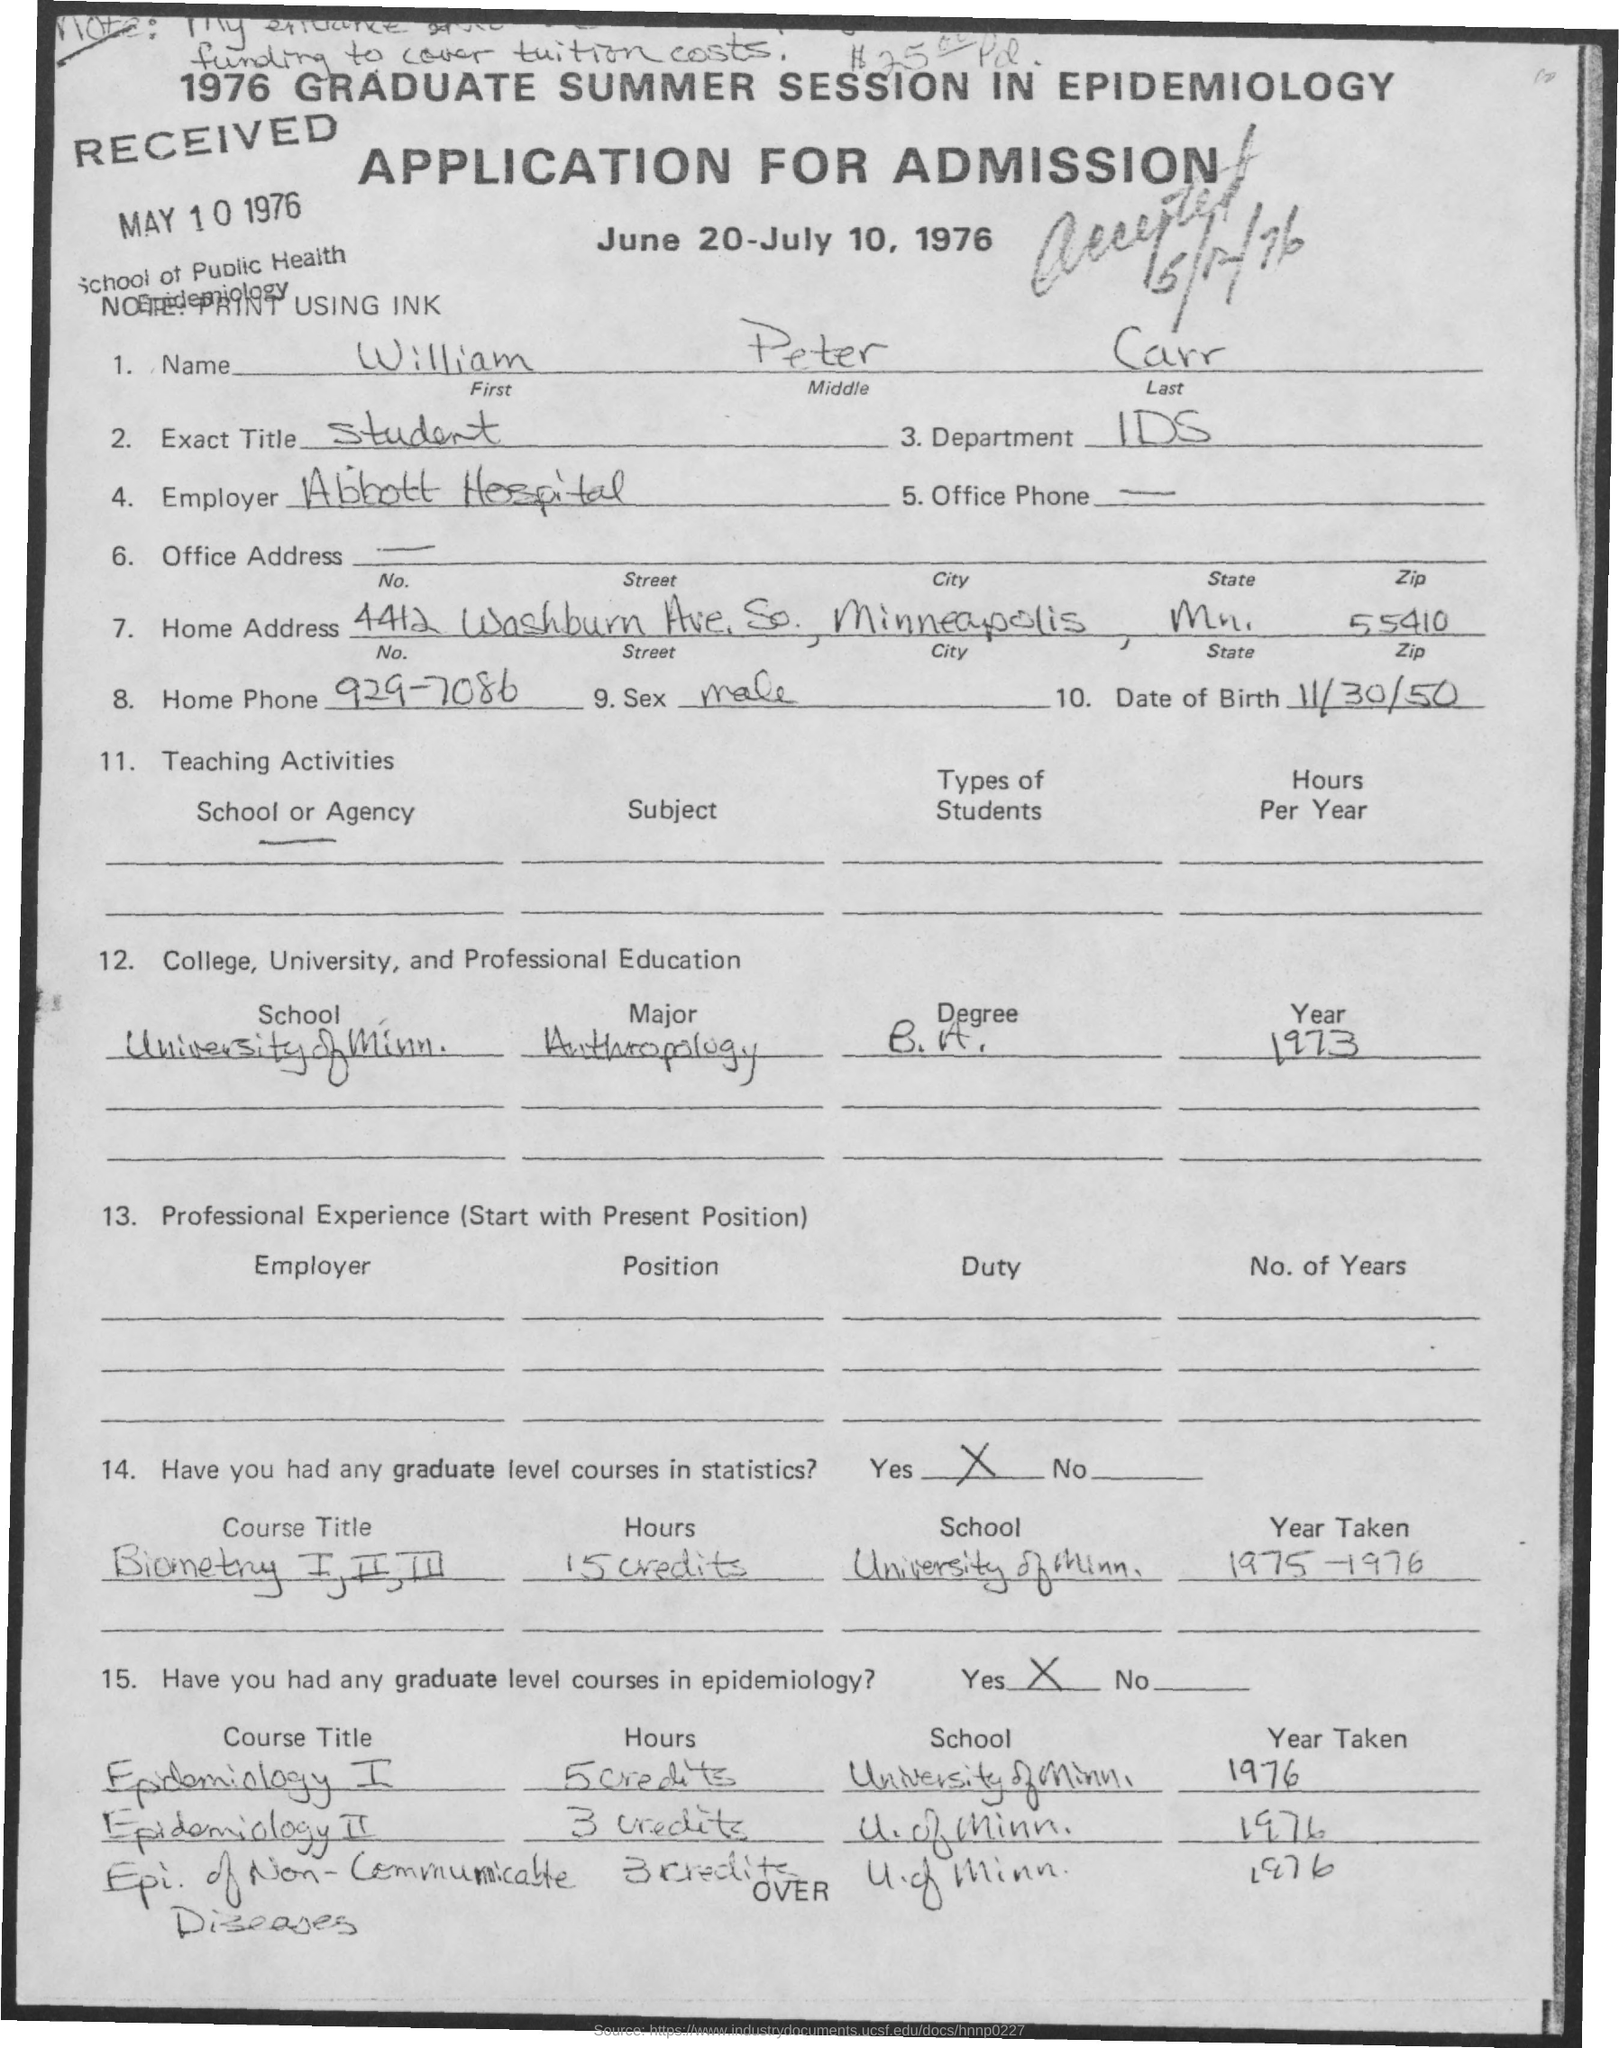Indicate a few pertinent items in this graphic. The given application mentions the middle name as "Peter. I'm sorry, but I am not sure what application you are referring to. Could you please provide more context or information so I can better understand your question and provide a clear and accurate response? The given application includes a home phone number, which is 929-7086. What is the name of the department mentioned in the given application? It is the IDS department. The last name mentioned in the given application is Carr. 